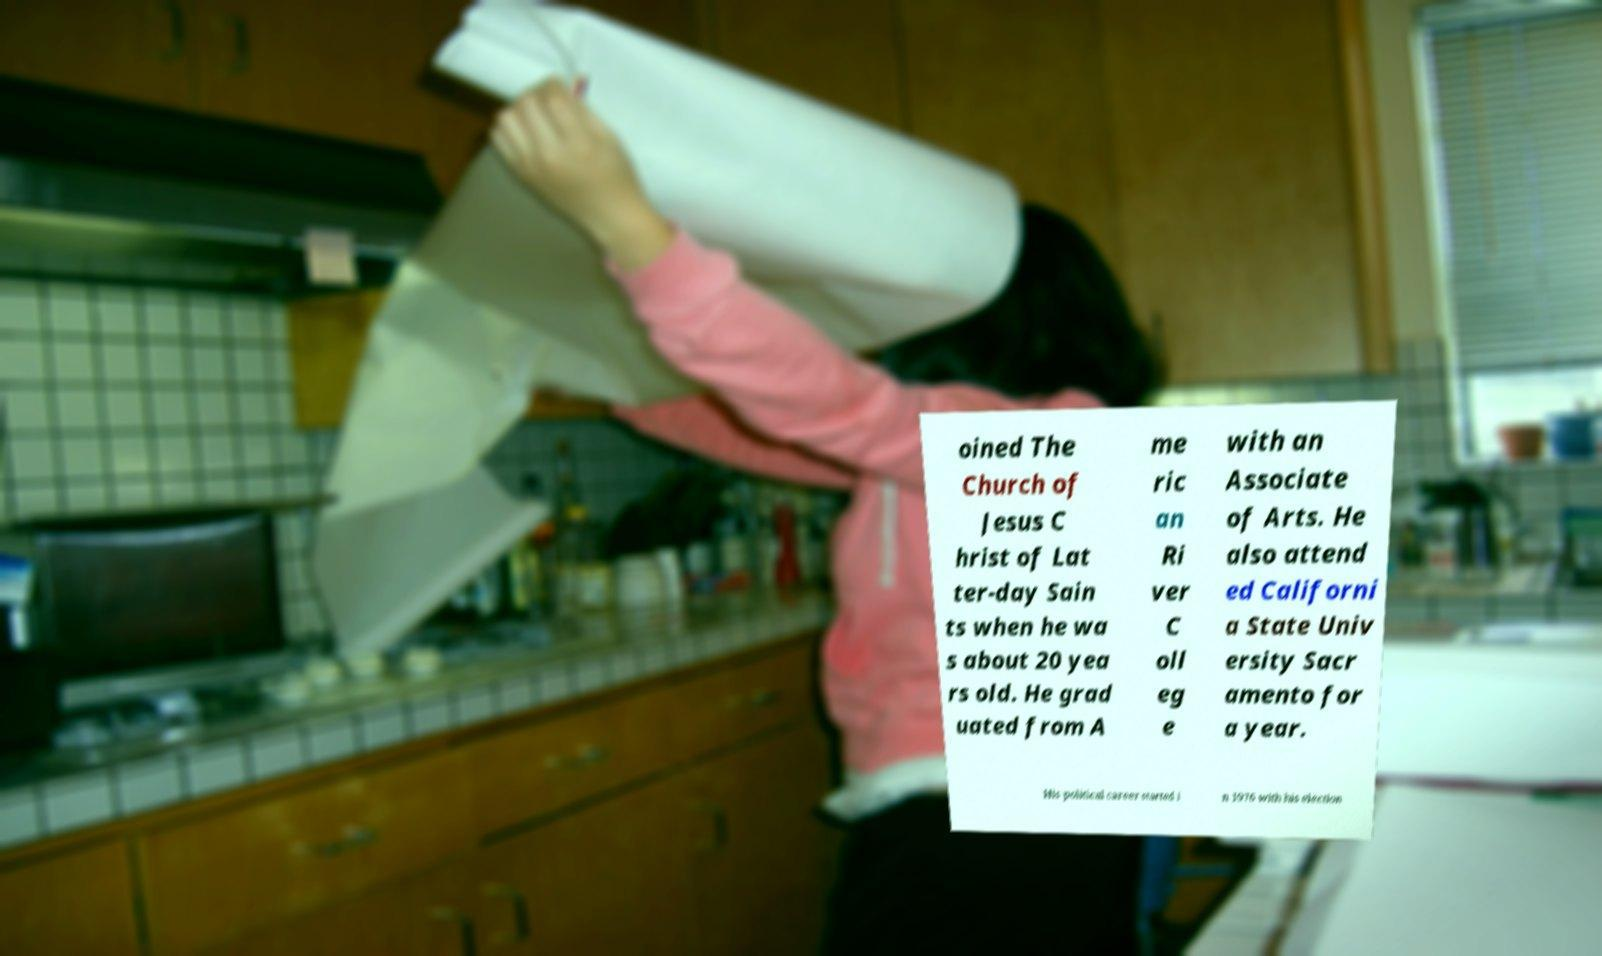Can you accurately transcribe the text from the provided image for me? oined The Church of Jesus C hrist of Lat ter-day Sain ts when he wa s about 20 yea rs old. He grad uated from A me ric an Ri ver C oll eg e with an Associate of Arts. He also attend ed Californi a State Univ ersity Sacr amento for a year. His political career started i n 1976 with his election 